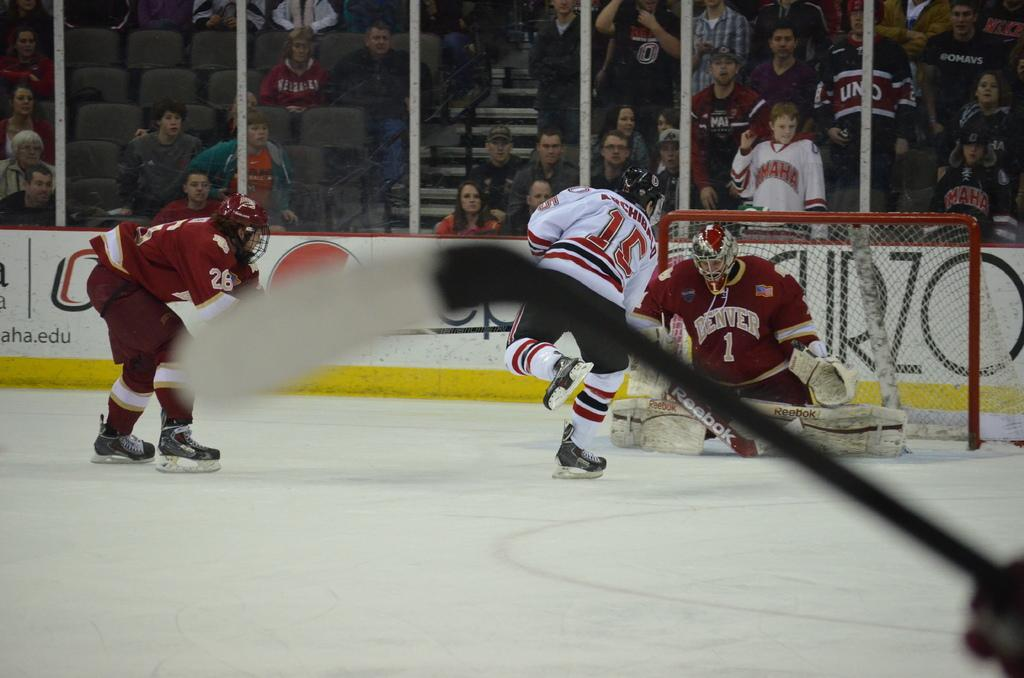<image>
Summarize the visual content of the image. a goalie that is wearing a Denver jersey on the ice 